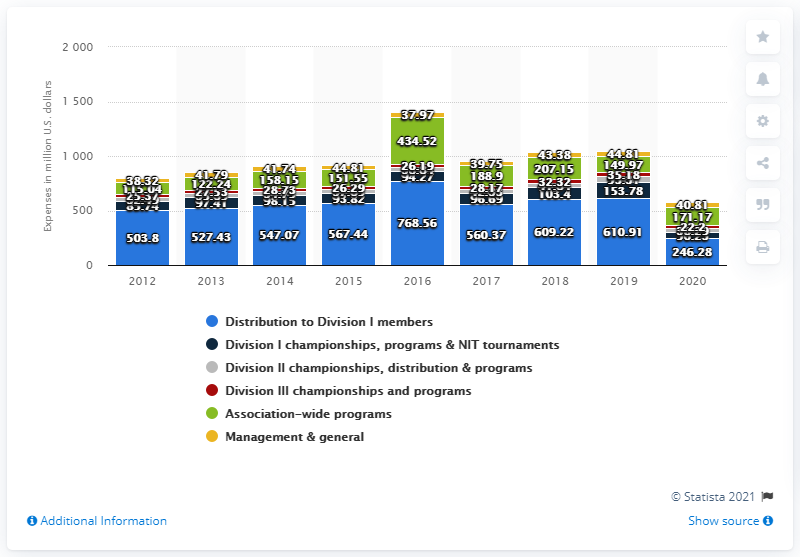Mention a couple of crucial points in this snapshot. The Division I members received a total of 246.28 million in the 2020 financial year. 